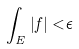Convert formula to latex. <formula><loc_0><loc_0><loc_500><loc_500>\int _ { E } | f | < \epsilon</formula> 